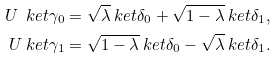Convert formula to latex. <formula><loc_0><loc_0><loc_500><loc_500>U \ k e t { \gamma _ { 0 } } & = \sqrt { \lambda } \ k e t { \delta _ { 0 } } + \sqrt { 1 - \lambda } \ k e t { \delta _ { 1 } } , \\ U \ k e t { \gamma _ { 1 } } & = \sqrt { 1 - \lambda } \ k e t { \delta _ { 0 } } - \sqrt { \lambda } \ k e t { \delta _ { 1 } } .</formula> 